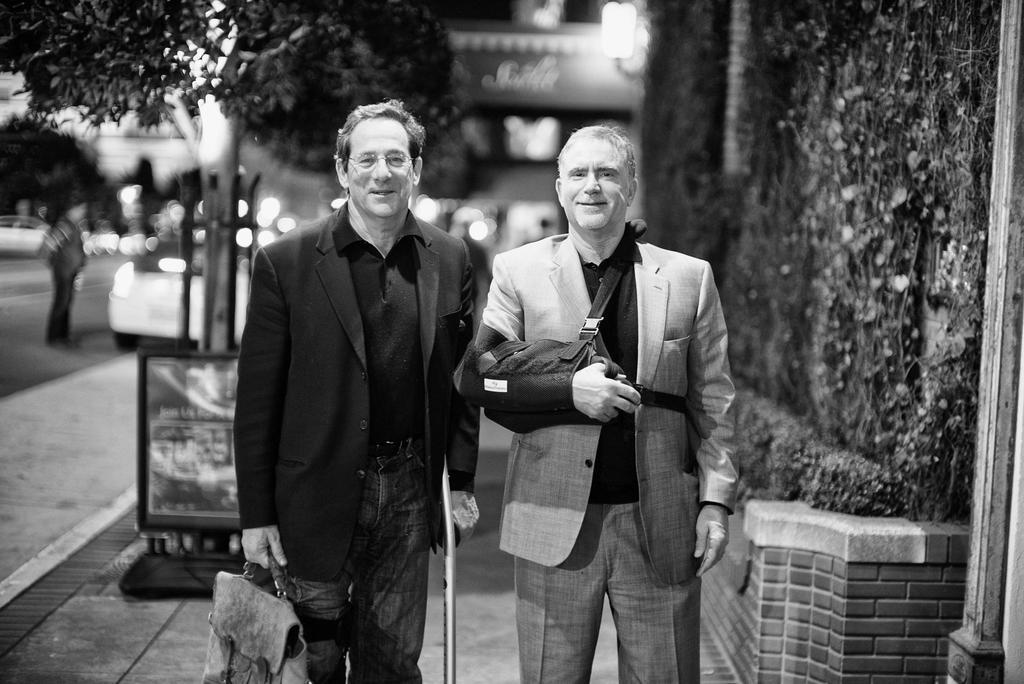In one or two sentences, can you explain what this image depicts? In this image in the foreground there are two persons who are standing and in the background there are some buildings, trees and some vehicles. On the left side there is one person who is standing and there are some boards and poles. On the right side there is a wall and some plants. 